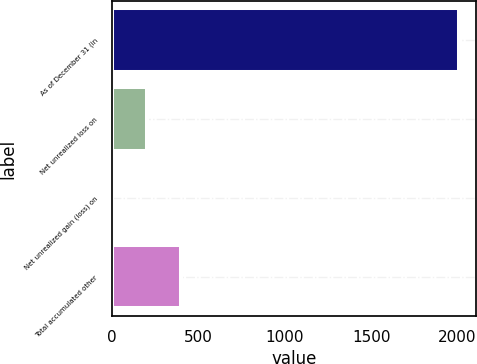Convert chart. <chart><loc_0><loc_0><loc_500><loc_500><bar_chart><fcel>As of December 31 (in<fcel>Net unrealized loss on<fcel>Net unrealized gain (loss) on<fcel>Total accumulated other<nl><fcel>2006<fcel>200.69<fcel>0.1<fcel>401.28<nl></chart> 